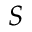Convert formula to latex. <formula><loc_0><loc_0><loc_500><loc_500>S</formula> 